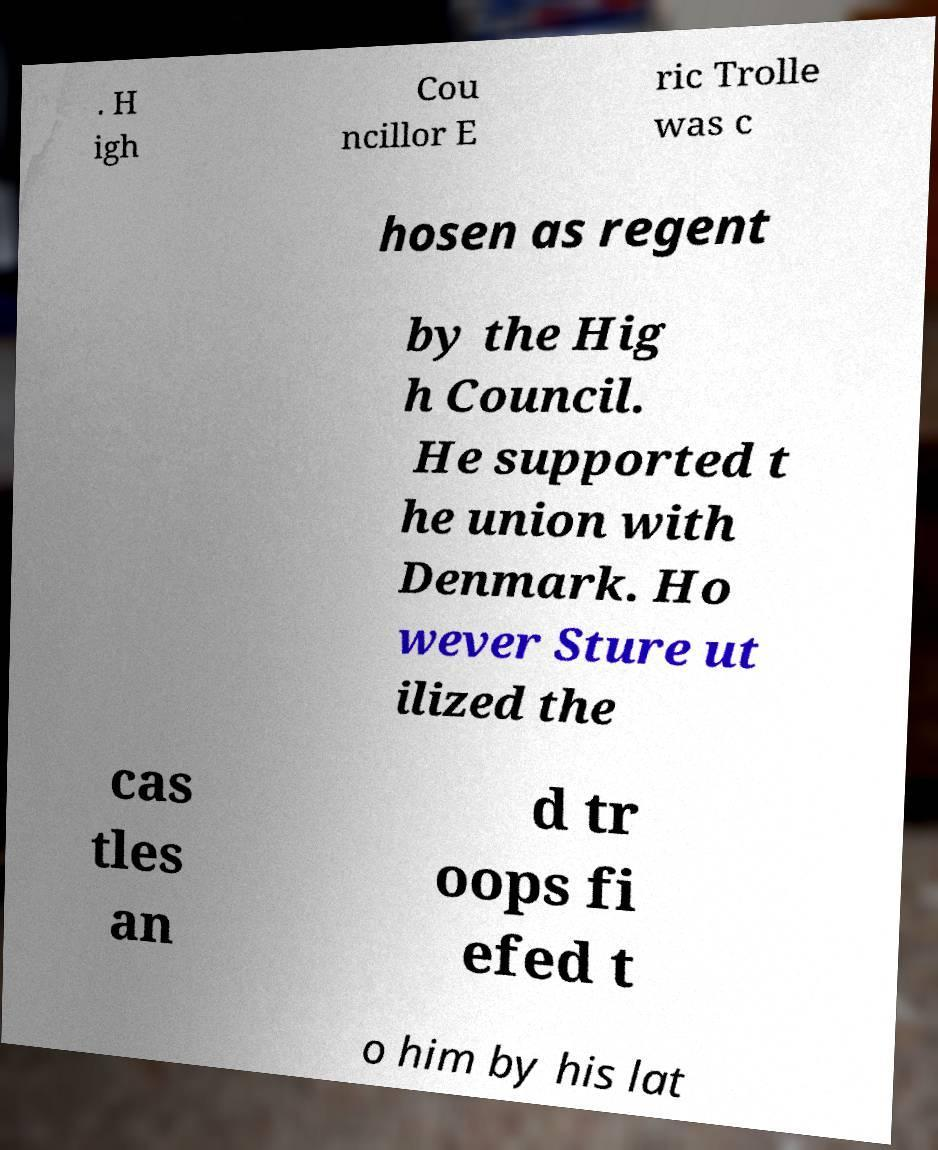Can you accurately transcribe the text from the provided image for me? . H igh Cou ncillor E ric Trolle was c hosen as regent by the Hig h Council. He supported t he union with Denmark. Ho wever Sture ut ilized the cas tles an d tr oops fi efed t o him by his lat 